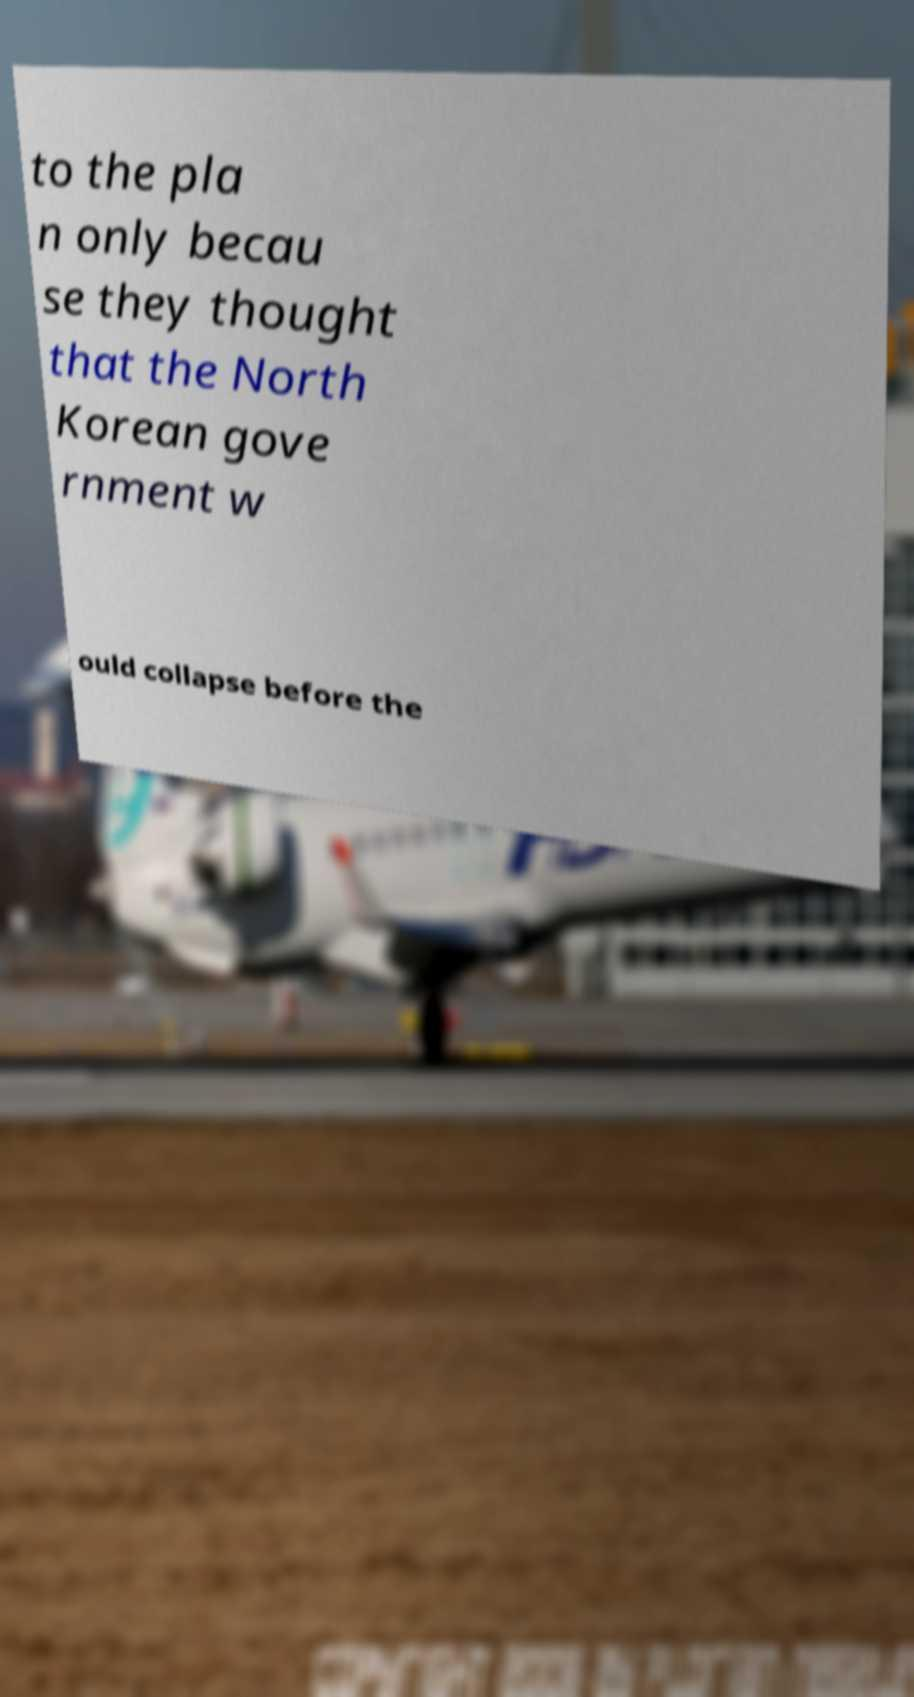Could you assist in decoding the text presented in this image and type it out clearly? to the pla n only becau se they thought that the North Korean gove rnment w ould collapse before the 